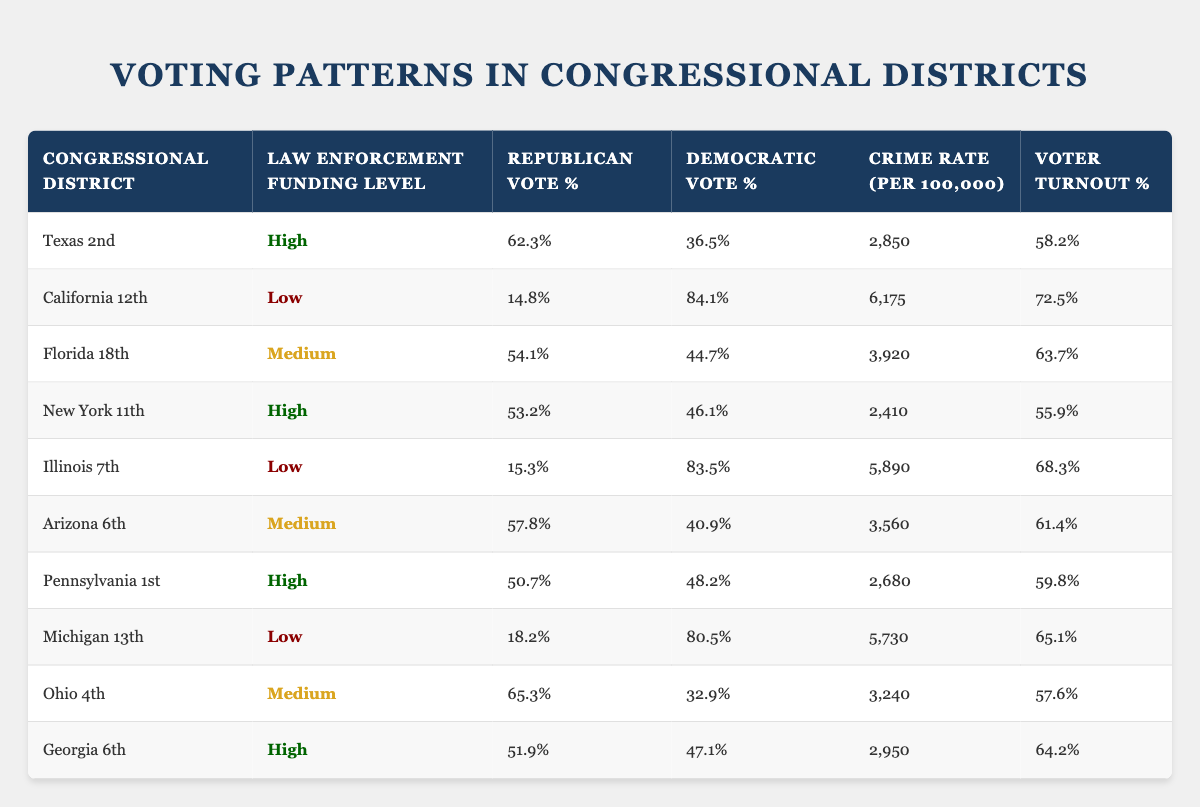What is the voter turnout percentage in California 12th? The table shows that California 12th has a voter turnout percentage of 72.5%. This information is directly found in the row corresponding to California 12th under the Voter Turnout % column.
Answer: 72.5% Which congressional district has the highest Republican vote percentage? By examining the Republican Vote % column, Texas 2nd has the highest percentage at 62.3%. This is directly observed by comparing the percentages in the Republican Vote % column across all districts.
Answer: Texas 2nd Is the crime rate in Florida 18th higher than that in New York 11th? The crime rate for Florida 18th is 3,920, while New York 11th has a crime rate of 2,410. Since 3,920 is greater than 2,410, the statement is true.
Answer: Yes What is the average Democratic vote percentage for districts with high law enforcement funding? The districts with high funding are Texas 2nd (36.5%), New York 11th (46.1%), Pennsylvania 1st (48.2%), and Georgia 6th (47.1%). To find the average, we sum these values (36.5 + 46.1 + 48.2 + 47.1 = 178.9) and divide by 4, which gives us an average of 44.725%.
Answer: 44.725% Is the voter turnout percentage in high funding districts generally lower than in low funding districts? Voter turnout percentages for high funding districts are: Texas 2nd (58.2%), New York 11th (55.9%), Pennsylvania 1st (59.8%), and Georgia 6th (64.2%) - average is 59.03%. Low funding districts are California 12th (72.5%), Illinois 7th (68.3%), and Michigan 13th (65.1%) - average is 68.33%. Since 59.03% is not lower than 68.33%, the statement is false.
Answer: No 